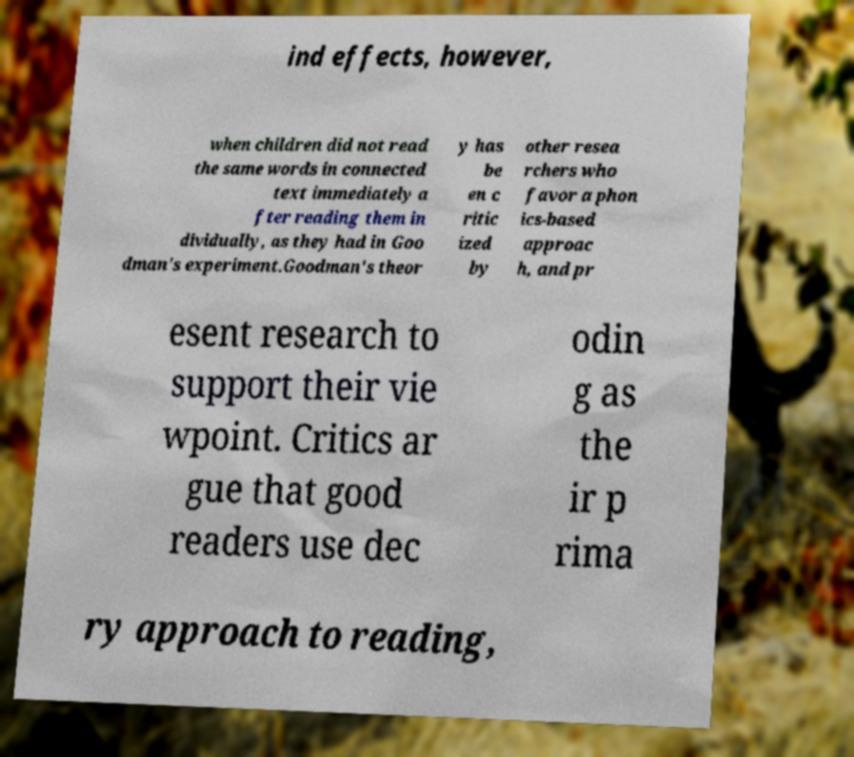Could you assist in decoding the text presented in this image and type it out clearly? ind effects, however, when children did not read the same words in connected text immediately a fter reading them in dividually, as they had in Goo dman's experiment.Goodman's theor y has be en c ritic ized by other resea rchers who favor a phon ics-based approac h, and pr esent research to support their vie wpoint. Critics ar gue that good readers use dec odin g as the ir p rima ry approach to reading, 